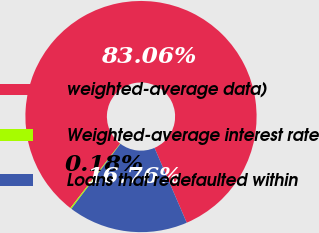Convert chart to OTSL. <chart><loc_0><loc_0><loc_500><loc_500><pie_chart><fcel>weighted-average data)<fcel>Weighted-average interest rate<fcel>Loans that redefaulted within<nl><fcel>83.06%<fcel>0.18%<fcel>16.76%<nl></chart> 